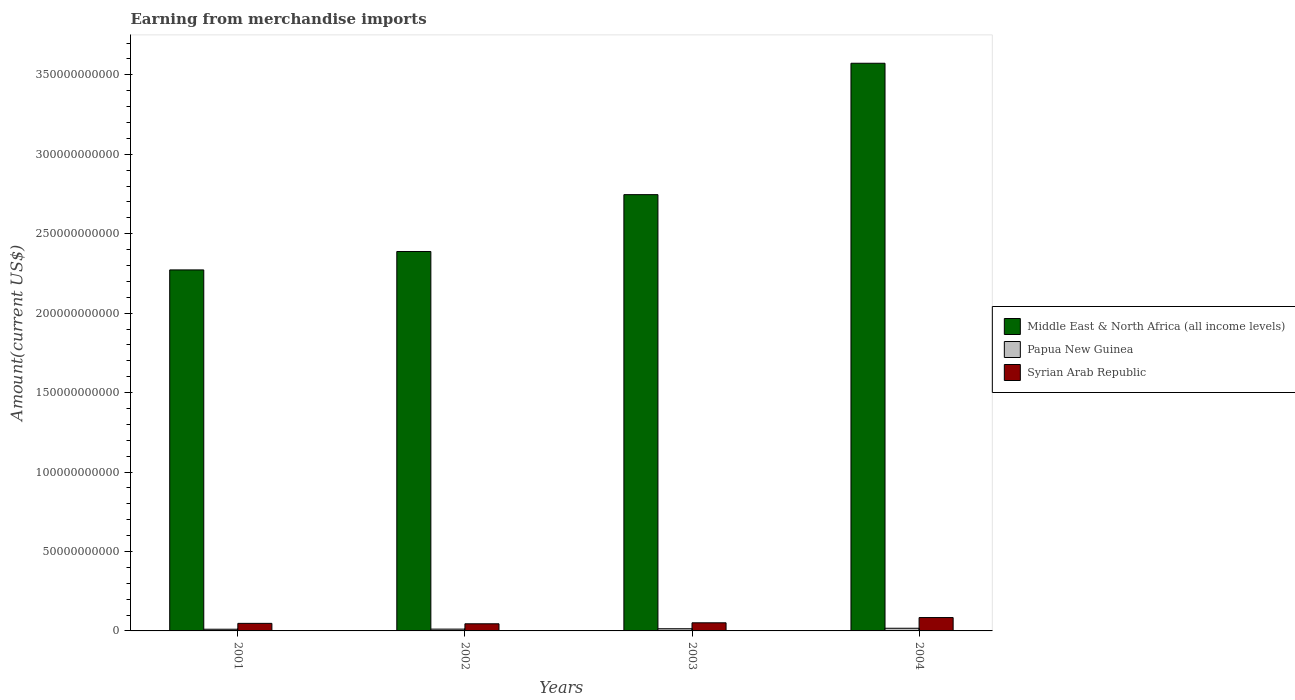How many groups of bars are there?
Offer a terse response. 4. Are the number of bars per tick equal to the number of legend labels?
Make the answer very short. Yes. Are the number of bars on each tick of the X-axis equal?
Your answer should be very brief. Yes. How many bars are there on the 3rd tick from the left?
Your answer should be very brief. 3. What is the label of the 1st group of bars from the left?
Offer a very short reply. 2001. What is the amount earned from merchandise imports in Syrian Arab Republic in 2001?
Your answer should be compact. 4.75e+09. Across all years, what is the maximum amount earned from merchandise imports in Syrian Arab Republic?
Offer a very short reply. 8.41e+09. Across all years, what is the minimum amount earned from merchandise imports in Syrian Arab Republic?
Your answer should be compact. 4.49e+09. What is the total amount earned from merchandise imports in Syrian Arab Republic in the graph?
Your answer should be compact. 2.28e+1. What is the difference between the amount earned from merchandise imports in Middle East & North Africa (all income levels) in 2002 and that in 2004?
Make the answer very short. -1.18e+11. What is the difference between the amount earned from merchandise imports in Syrian Arab Republic in 2001 and the amount earned from merchandise imports in Papua New Guinea in 2002?
Ensure brevity in your answer.  3.62e+09. What is the average amount earned from merchandise imports in Middle East & North Africa (all income levels) per year?
Offer a very short reply. 2.74e+11. In the year 2003, what is the difference between the amount earned from merchandise imports in Syrian Arab Republic and amount earned from merchandise imports in Papua New Guinea?
Offer a terse response. 3.74e+09. What is the ratio of the amount earned from merchandise imports in Papua New Guinea in 2001 to that in 2004?
Give a very brief answer. 0.64. Is the difference between the amount earned from merchandise imports in Syrian Arab Republic in 2001 and 2004 greater than the difference between the amount earned from merchandise imports in Papua New Guinea in 2001 and 2004?
Provide a short and direct response. No. What is the difference between the highest and the second highest amount earned from merchandise imports in Papua New Guinea?
Provide a short and direct response. 3.13e+08. What is the difference between the highest and the lowest amount earned from merchandise imports in Papua New Guinea?
Offer a terse response. 6.09e+08. Is the sum of the amount earned from merchandise imports in Papua New Guinea in 2001 and 2002 greater than the maximum amount earned from merchandise imports in Middle East & North Africa (all income levels) across all years?
Give a very brief answer. No. What does the 1st bar from the left in 2002 represents?
Provide a short and direct response. Middle East & North Africa (all income levels). What does the 2nd bar from the right in 2001 represents?
Provide a succinct answer. Papua New Guinea. Is it the case that in every year, the sum of the amount earned from merchandise imports in Papua New Guinea and amount earned from merchandise imports in Middle East & North Africa (all income levels) is greater than the amount earned from merchandise imports in Syrian Arab Republic?
Your answer should be compact. Yes. How many years are there in the graph?
Offer a terse response. 4. Are the values on the major ticks of Y-axis written in scientific E-notation?
Your answer should be very brief. No. Does the graph contain any zero values?
Provide a succinct answer. No. Does the graph contain grids?
Your response must be concise. No. What is the title of the graph?
Your answer should be very brief. Earning from merchandise imports. Does "Belarus" appear as one of the legend labels in the graph?
Make the answer very short. No. What is the label or title of the Y-axis?
Keep it short and to the point. Amount(current US$). What is the Amount(current US$) in Middle East & North Africa (all income levels) in 2001?
Your response must be concise. 2.27e+11. What is the Amount(current US$) in Papua New Guinea in 2001?
Provide a succinct answer. 1.07e+09. What is the Amount(current US$) of Syrian Arab Republic in 2001?
Your response must be concise. 4.75e+09. What is the Amount(current US$) of Middle East & North Africa (all income levels) in 2002?
Provide a succinct answer. 2.39e+11. What is the Amount(current US$) of Papua New Guinea in 2002?
Provide a succinct answer. 1.14e+09. What is the Amount(current US$) of Syrian Arab Republic in 2002?
Keep it short and to the point. 4.49e+09. What is the Amount(current US$) of Middle East & North Africa (all income levels) in 2003?
Your answer should be compact. 2.75e+11. What is the Amount(current US$) of Papua New Guinea in 2003?
Make the answer very short. 1.37e+09. What is the Amount(current US$) of Syrian Arab Republic in 2003?
Provide a short and direct response. 5.11e+09. What is the Amount(current US$) in Middle East & North Africa (all income levels) in 2004?
Your answer should be very brief. 3.57e+11. What is the Amount(current US$) of Papua New Guinea in 2004?
Offer a terse response. 1.68e+09. What is the Amount(current US$) of Syrian Arab Republic in 2004?
Offer a very short reply. 8.41e+09. Across all years, what is the maximum Amount(current US$) of Middle East & North Africa (all income levels)?
Offer a very short reply. 3.57e+11. Across all years, what is the maximum Amount(current US$) of Papua New Guinea?
Your answer should be very brief. 1.68e+09. Across all years, what is the maximum Amount(current US$) of Syrian Arab Republic?
Give a very brief answer. 8.41e+09. Across all years, what is the minimum Amount(current US$) in Middle East & North Africa (all income levels)?
Provide a succinct answer. 2.27e+11. Across all years, what is the minimum Amount(current US$) of Papua New Guinea?
Your answer should be compact. 1.07e+09. Across all years, what is the minimum Amount(current US$) in Syrian Arab Republic?
Your answer should be very brief. 4.49e+09. What is the total Amount(current US$) of Middle East & North Africa (all income levels) in the graph?
Ensure brevity in your answer.  1.10e+12. What is the total Amount(current US$) in Papua New Guinea in the graph?
Your answer should be very brief. 5.25e+09. What is the total Amount(current US$) of Syrian Arab Republic in the graph?
Your answer should be very brief. 2.28e+1. What is the difference between the Amount(current US$) of Middle East & North Africa (all income levels) in 2001 and that in 2002?
Keep it short and to the point. -1.16e+1. What is the difference between the Amount(current US$) of Papua New Guinea in 2001 and that in 2002?
Offer a very short reply. -6.60e+07. What is the difference between the Amount(current US$) of Syrian Arab Republic in 2001 and that in 2002?
Your answer should be compact. 2.64e+08. What is the difference between the Amount(current US$) in Middle East & North Africa (all income levels) in 2001 and that in 2003?
Make the answer very short. -4.74e+1. What is the difference between the Amount(current US$) in Papua New Guinea in 2001 and that in 2003?
Provide a succinct answer. -2.96e+08. What is the difference between the Amount(current US$) of Syrian Arab Republic in 2001 and that in 2003?
Your answer should be compact. -3.59e+08. What is the difference between the Amount(current US$) of Middle East & North Africa (all income levels) in 2001 and that in 2004?
Make the answer very short. -1.30e+11. What is the difference between the Amount(current US$) in Papua New Guinea in 2001 and that in 2004?
Your answer should be very brief. -6.09e+08. What is the difference between the Amount(current US$) in Syrian Arab Republic in 2001 and that in 2004?
Offer a terse response. -3.66e+09. What is the difference between the Amount(current US$) of Middle East & North Africa (all income levels) in 2002 and that in 2003?
Your response must be concise. -3.58e+1. What is the difference between the Amount(current US$) in Papua New Guinea in 2002 and that in 2003?
Your answer should be compact. -2.30e+08. What is the difference between the Amount(current US$) of Syrian Arab Republic in 2002 and that in 2003?
Ensure brevity in your answer.  -6.23e+08. What is the difference between the Amount(current US$) of Middle East & North Africa (all income levels) in 2002 and that in 2004?
Give a very brief answer. -1.18e+11. What is the difference between the Amount(current US$) of Papua New Guinea in 2002 and that in 2004?
Offer a very short reply. -5.43e+08. What is the difference between the Amount(current US$) of Syrian Arab Republic in 2002 and that in 2004?
Offer a terse response. -3.92e+09. What is the difference between the Amount(current US$) in Middle East & North Africa (all income levels) in 2003 and that in 2004?
Your answer should be compact. -8.27e+1. What is the difference between the Amount(current US$) in Papua New Guinea in 2003 and that in 2004?
Keep it short and to the point. -3.13e+08. What is the difference between the Amount(current US$) in Syrian Arab Republic in 2003 and that in 2004?
Offer a terse response. -3.30e+09. What is the difference between the Amount(current US$) in Middle East & North Africa (all income levels) in 2001 and the Amount(current US$) in Papua New Guinea in 2002?
Your answer should be very brief. 2.26e+11. What is the difference between the Amount(current US$) of Middle East & North Africa (all income levels) in 2001 and the Amount(current US$) of Syrian Arab Republic in 2002?
Offer a very short reply. 2.23e+11. What is the difference between the Amount(current US$) in Papua New Guinea in 2001 and the Amount(current US$) in Syrian Arab Republic in 2002?
Give a very brief answer. -3.42e+09. What is the difference between the Amount(current US$) in Middle East & North Africa (all income levels) in 2001 and the Amount(current US$) in Papua New Guinea in 2003?
Your answer should be very brief. 2.26e+11. What is the difference between the Amount(current US$) in Middle East & North Africa (all income levels) in 2001 and the Amount(current US$) in Syrian Arab Republic in 2003?
Provide a succinct answer. 2.22e+11. What is the difference between the Amount(current US$) of Papua New Guinea in 2001 and the Amount(current US$) of Syrian Arab Republic in 2003?
Ensure brevity in your answer.  -4.04e+09. What is the difference between the Amount(current US$) in Middle East & North Africa (all income levels) in 2001 and the Amount(current US$) in Papua New Guinea in 2004?
Offer a terse response. 2.26e+11. What is the difference between the Amount(current US$) in Middle East & North Africa (all income levels) in 2001 and the Amount(current US$) in Syrian Arab Republic in 2004?
Keep it short and to the point. 2.19e+11. What is the difference between the Amount(current US$) of Papua New Guinea in 2001 and the Amount(current US$) of Syrian Arab Republic in 2004?
Your answer should be compact. -7.34e+09. What is the difference between the Amount(current US$) in Middle East & North Africa (all income levels) in 2002 and the Amount(current US$) in Papua New Guinea in 2003?
Your response must be concise. 2.37e+11. What is the difference between the Amount(current US$) of Middle East & North Africa (all income levels) in 2002 and the Amount(current US$) of Syrian Arab Republic in 2003?
Provide a succinct answer. 2.34e+11. What is the difference between the Amount(current US$) in Papua New Guinea in 2002 and the Amount(current US$) in Syrian Arab Republic in 2003?
Keep it short and to the point. -3.97e+09. What is the difference between the Amount(current US$) of Middle East & North Africa (all income levels) in 2002 and the Amount(current US$) of Papua New Guinea in 2004?
Offer a very short reply. 2.37e+11. What is the difference between the Amount(current US$) in Middle East & North Africa (all income levels) in 2002 and the Amount(current US$) in Syrian Arab Republic in 2004?
Provide a short and direct response. 2.30e+11. What is the difference between the Amount(current US$) in Papua New Guinea in 2002 and the Amount(current US$) in Syrian Arab Republic in 2004?
Offer a terse response. -7.27e+09. What is the difference between the Amount(current US$) of Middle East & North Africa (all income levels) in 2003 and the Amount(current US$) of Papua New Guinea in 2004?
Ensure brevity in your answer.  2.73e+11. What is the difference between the Amount(current US$) in Middle East & North Africa (all income levels) in 2003 and the Amount(current US$) in Syrian Arab Republic in 2004?
Make the answer very short. 2.66e+11. What is the difference between the Amount(current US$) of Papua New Guinea in 2003 and the Amount(current US$) of Syrian Arab Republic in 2004?
Make the answer very short. -7.04e+09. What is the average Amount(current US$) in Middle East & North Africa (all income levels) per year?
Offer a very short reply. 2.74e+11. What is the average Amount(current US$) of Papua New Guinea per year?
Offer a terse response. 1.31e+09. What is the average Amount(current US$) of Syrian Arab Republic per year?
Provide a short and direct response. 5.69e+09. In the year 2001, what is the difference between the Amount(current US$) of Middle East & North Africa (all income levels) and Amount(current US$) of Papua New Guinea?
Give a very brief answer. 2.26e+11. In the year 2001, what is the difference between the Amount(current US$) of Middle East & North Africa (all income levels) and Amount(current US$) of Syrian Arab Republic?
Ensure brevity in your answer.  2.22e+11. In the year 2001, what is the difference between the Amount(current US$) of Papua New Guinea and Amount(current US$) of Syrian Arab Republic?
Provide a short and direct response. -3.68e+09. In the year 2002, what is the difference between the Amount(current US$) in Middle East & North Africa (all income levels) and Amount(current US$) in Papua New Guinea?
Your answer should be very brief. 2.38e+11. In the year 2002, what is the difference between the Amount(current US$) of Middle East & North Africa (all income levels) and Amount(current US$) of Syrian Arab Republic?
Ensure brevity in your answer.  2.34e+11. In the year 2002, what is the difference between the Amount(current US$) of Papua New Guinea and Amount(current US$) of Syrian Arab Republic?
Your answer should be compact. -3.35e+09. In the year 2003, what is the difference between the Amount(current US$) in Middle East & North Africa (all income levels) and Amount(current US$) in Papua New Guinea?
Provide a succinct answer. 2.73e+11. In the year 2003, what is the difference between the Amount(current US$) in Middle East & North Africa (all income levels) and Amount(current US$) in Syrian Arab Republic?
Give a very brief answer. 2.69e+11. In the year 2003, what is the difference between the Amount(current US$) in Papua New Guinea and Amount(current US$) in Syrian Arab Republic?
Give a very brief answer. -3.74e+09. In the year 2004, what is the difference between the Amount(current US$) of Middle East & North Africa (all income levels) and Amount(current US$) of Papua New Guinea?
Provide a succinct answer. 3.56e+11. In the year 2004, what is the difference between the Amount(current US$) of Middle East & North Africa (all income levels) and Amount(current US$) of Syrian Arab Republic?
Provide a short and direct response. 3.49e+11. In the year 2004, what is the difference between the Amount(current US$) in Papua New Guinea and Amount(current US$) in Syrian Arab Republic?
Provide a succinct answer. -6.73e+09. What is the ratio of the Amount(current US$) in Middle East & North Africa (all income levels) in 2001 to that in 2002?
Provide a short and direct response. 0.95. What is the ratio of the Amount(current US$) in Papua New Guinea in 2001 to that in 2002?
Ensure brevity in your answer.  0.94. What is the ratio of the Amount(current US$) of Syrian Arab Republic in 2001 to that in 2002?
Ensure brevity in your answer.  1.06. What is the ratio of the Amount(current US$) of Middle East & North Africa (all income levels) in 2001 to that in 2003?
Give a very brief answer. 0.83. What is the ratio of the Amount(current US$) of Papua New Guinea in 2001 to that in 2003?
Your answer should be very brief. 0.78. What is the ratio of the Amount(current US$) of Syrian Arab Republic in 2001 to that in 2003?
Provide a succinct answer. 0.93. What is the ratio of the Amount(current US$) of Middle East & North Africa (all income levels) in 2001 to that in 2004?
Offer a very short reply. 0.64. What is the ratio of the Amount(current US$) of Papua New Guinea in 2001 to that in 2004?
Your answer should be compact. 0.64. What is the ratio of the Amount(current US$) in Syrian Arab Republic in 2001 to that in 2004?
Ensure brevity in your answer.  0.56. What is the ratio of the Amount(current US$) of Middle East & North Africa (all income levels) in 2002 to that in 2003?
Provide a short and direct response. 0.87. What is the ratio of the Amount(current US$) in Papua New Guinea in 2002 to that in 2003?
Offer a terse response. 0.83. What is the ratio of the Amount(current US$) in Syrian Arab Republic in 2002 to that in 2003?
Your response must be concise. 0.88. What is the ratio of the Amount(current US$) of Middle East & North Africa (all income levels) in 2002 to that in 2004?
Your answer should be compact. 0.67. What is the ratio of the Amount(current US$) of Papua New Guinea in 2002 to that in 2004?
Provide a short and direct response. 0.68. What is the ratio of the Amount(current US$) of Syrian Arab Republic in 2002 to that in 2004?
Offer a very short reply. 0.53. What is the ratio of the Amount(current US$) in Middle East & North Africa (all income levels) in 2003 to that in 2004?
Give a very brief answer. 0.77. What is the ratio of the Amount(current US$) of Papua New Guinea in 2003 to that in 2004?
Offer a terse response. 0.81. What is the ratio of the Amount(current US$) of Syrian Arab Republic in 2003 to that in 2004?
Offer a terse response. 0.61. What is the difference between the highest and the second highest Amount(current US$) of Middle East & North Africa (all income levels)?
Make the answer very short. 8.27e+1. What is the difference between the highest and the second highest Amount(current US$) of Papua New Guinea?
Give a very brief answer. 3.13e+08. What is the difference between the highest and the second highest Amount(current US$) in Syrian Arab Republic?
Your answer should be very brief. 3.30e+09. What is the difference between the highest and the lowest Amount(current US$) of Middle East & North Africa (all income levels)?
Give a very brief answer. 1.30e+11. What is the difference between the highest and the lowest Amount(current US$) in Papua New Guinea?
Your answer should be very brief. 6.09e+08. What is the difference between the highest and the lowest Amount(current US$) in Syrian Arab Republic?
Ensure brevity in your answer.  3.92e+09. 